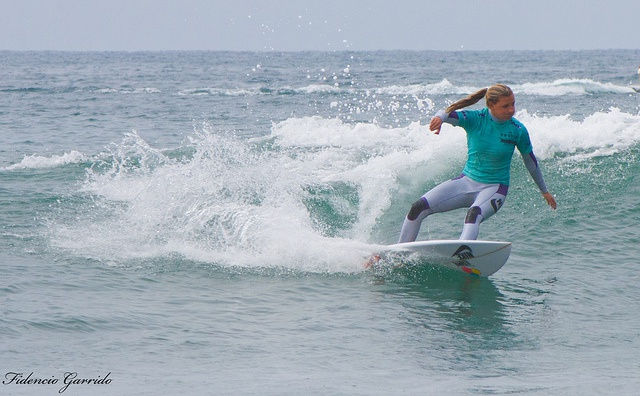Describe the objects in this image and their specific colors. I can see people in darkgray, teal, and gray tones and surfboard in darkgray, gray, and teal tones in this image. 